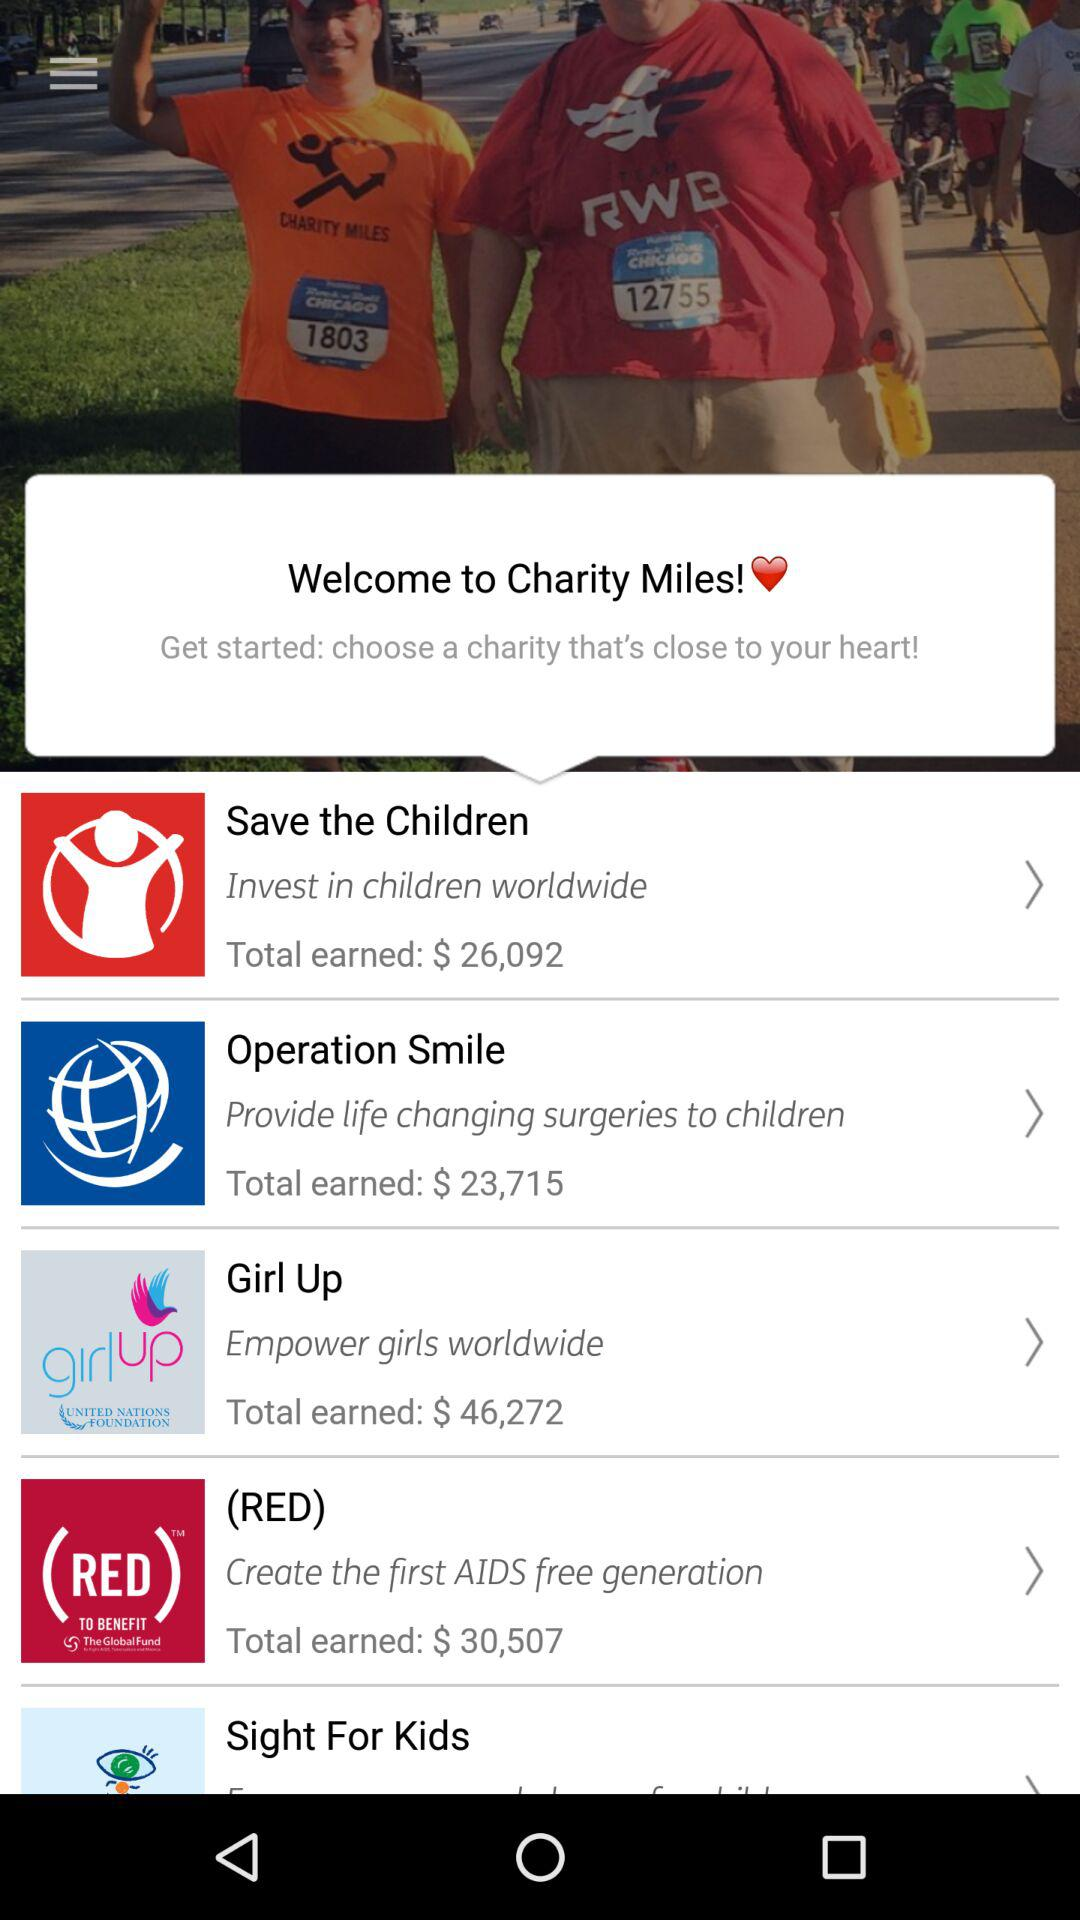Which organization works for the empowerment of girls? The organization that works for the empowerment of girls is "Girl Up". 